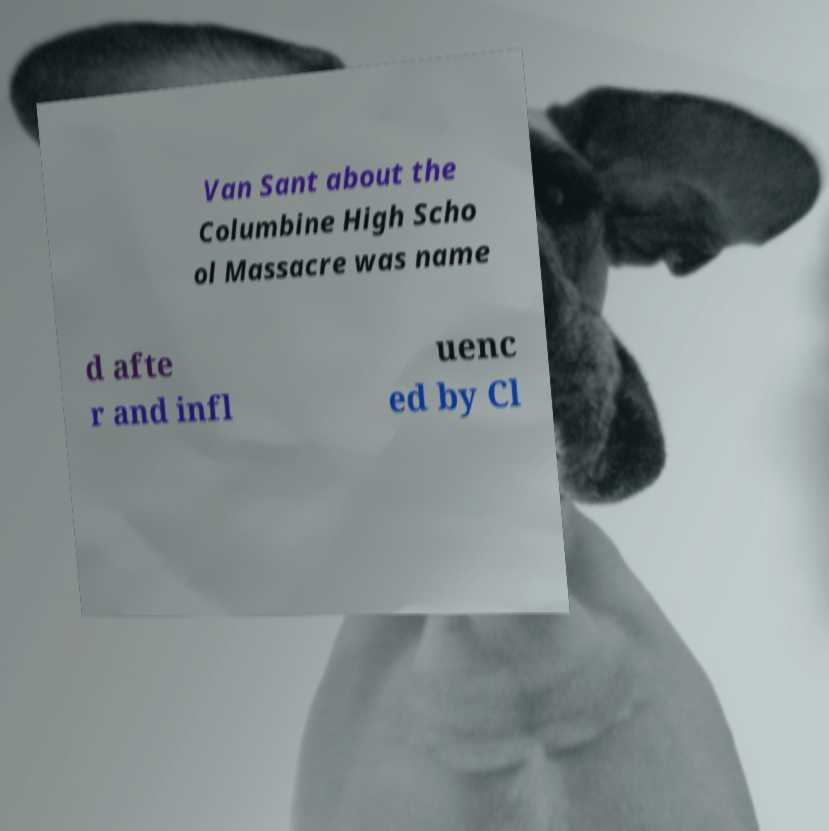Could you extract and type out the text from this image? Van Sant about the Columbine High Scho ol Massacre was name d afte r and infl uenc ed by Cl 